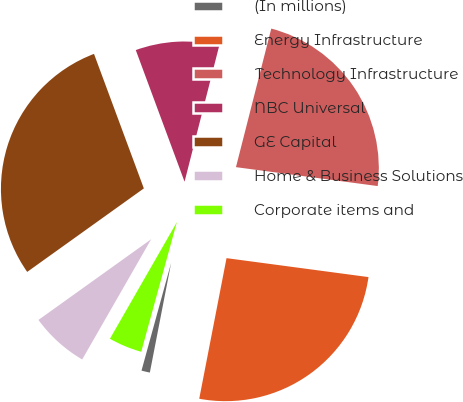Convert chart. <chart><loc_0><loc_0><loc_500><loc_500><pie_chart><fcel>(In millions)<fcel>Energy Infrastructure<fcel>Technology Infrastructure<fcel>NBC Universal<fcel>GE Capital<fcel>Home & Business Solutions<fcel>Corporate items and<nl><fcel>1.22%<fcel>25.94%<fcel>23.14%<fcel>9.62%<fcel>29.24%<fcel>6.82%<fcel>4.02%<nl></chart> 